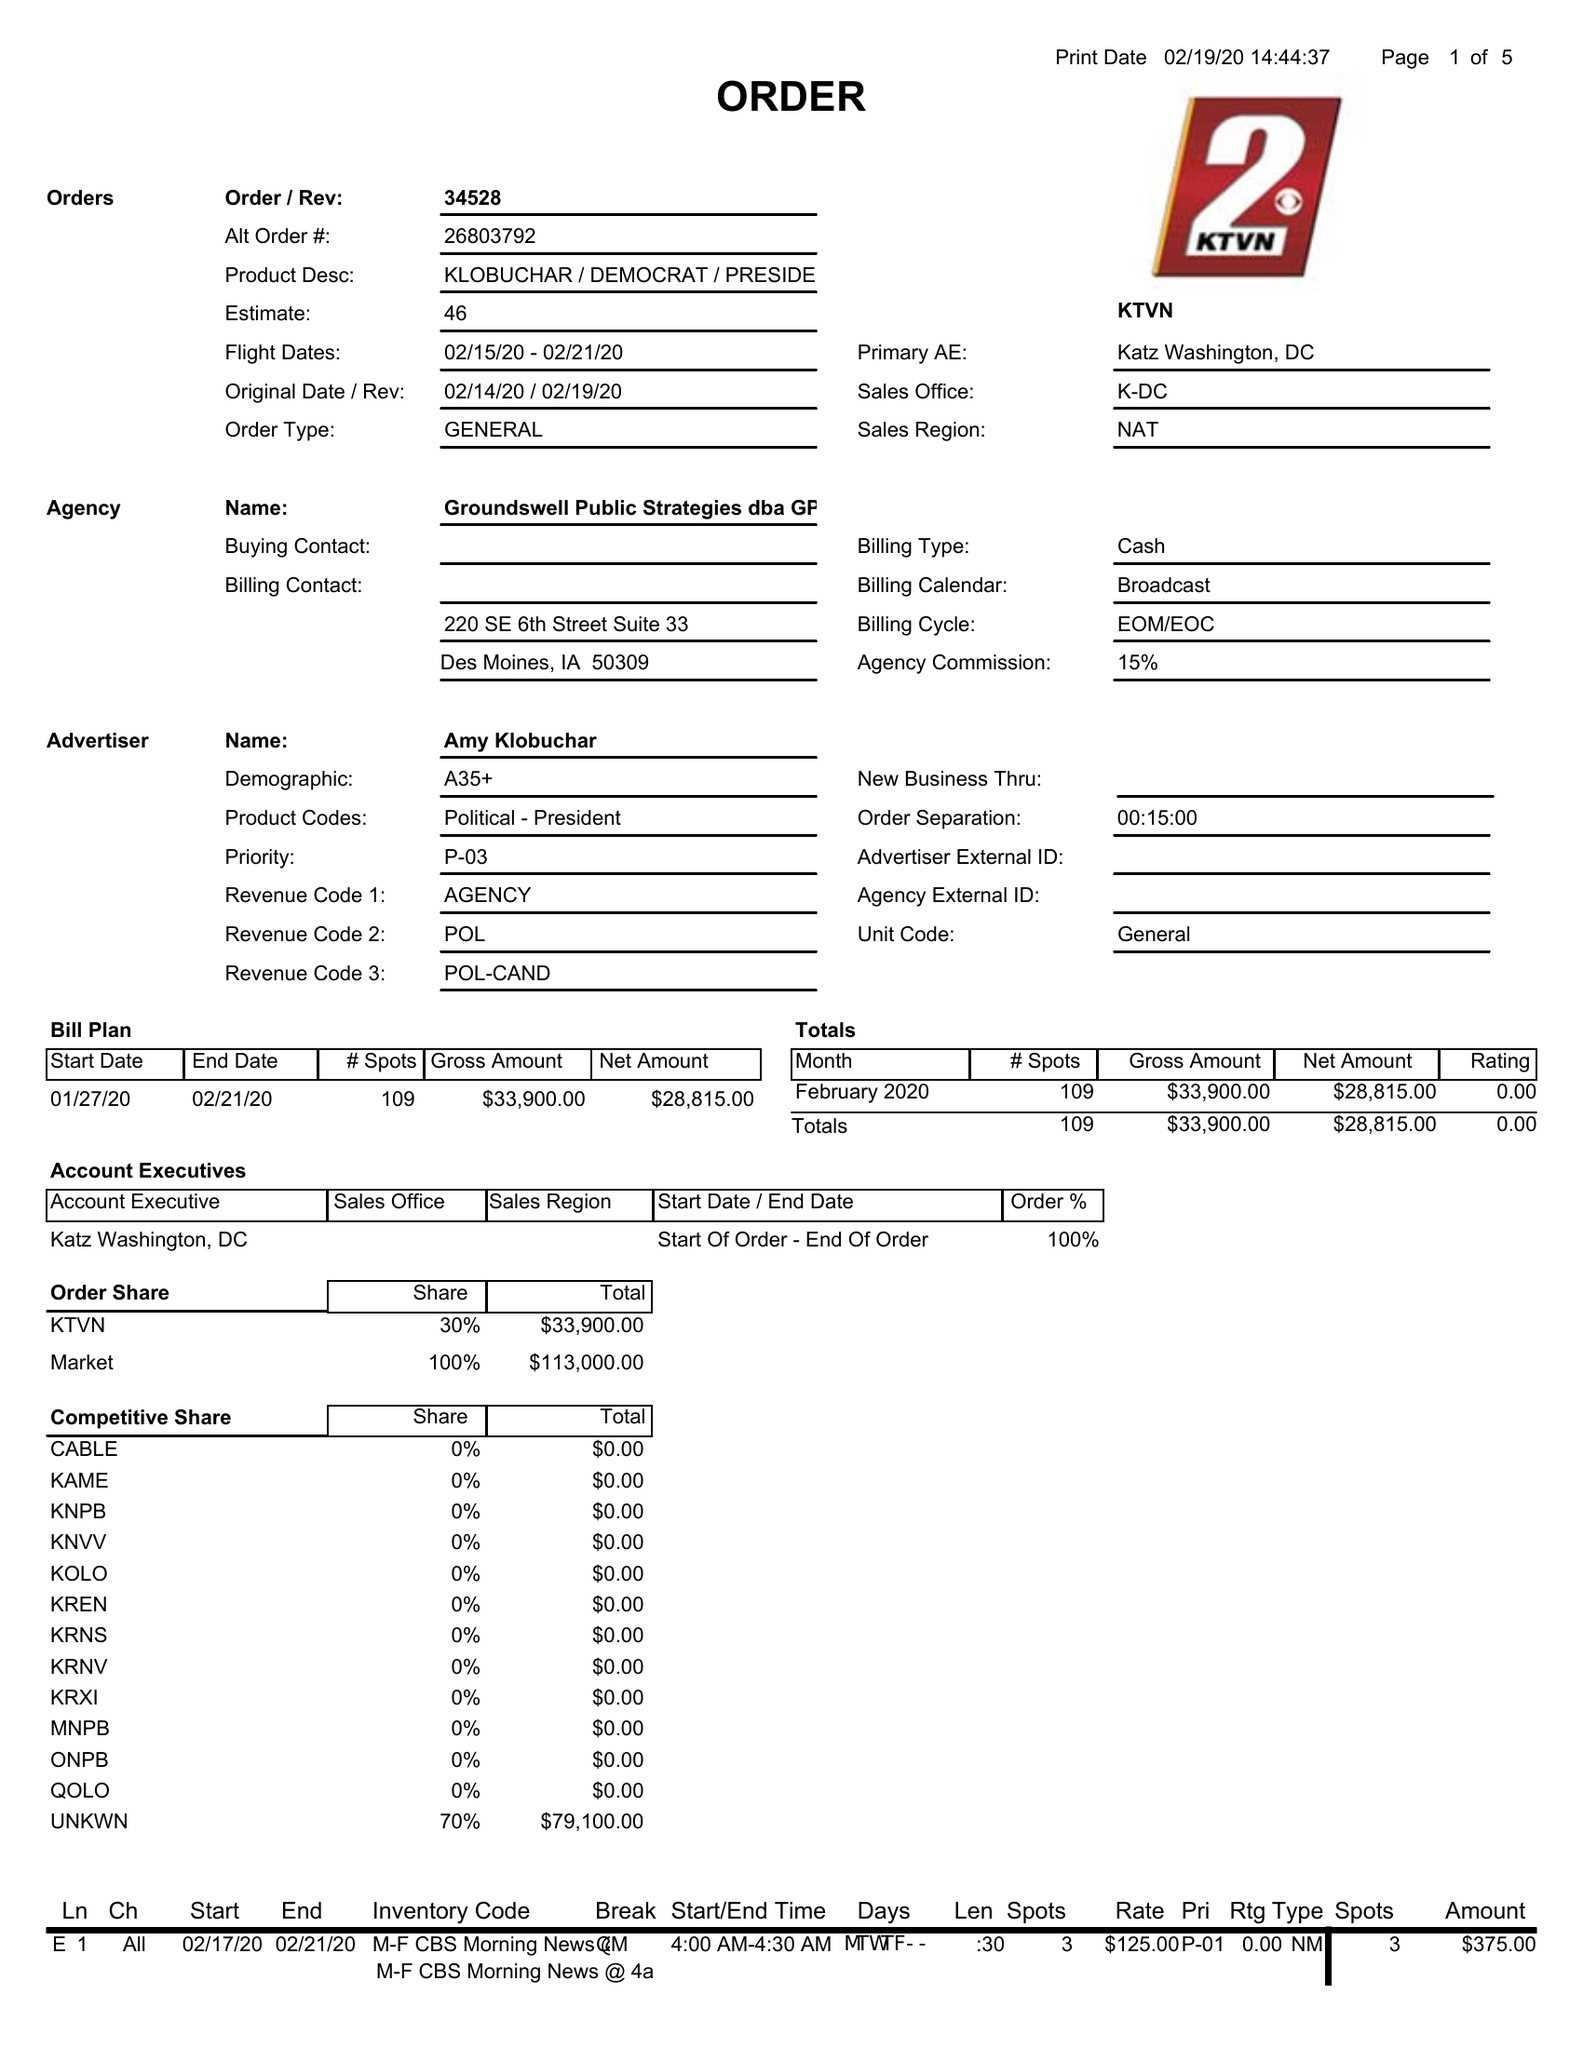What is the value for the contract_num?
Answer the question using a single word or phrase. 34528 